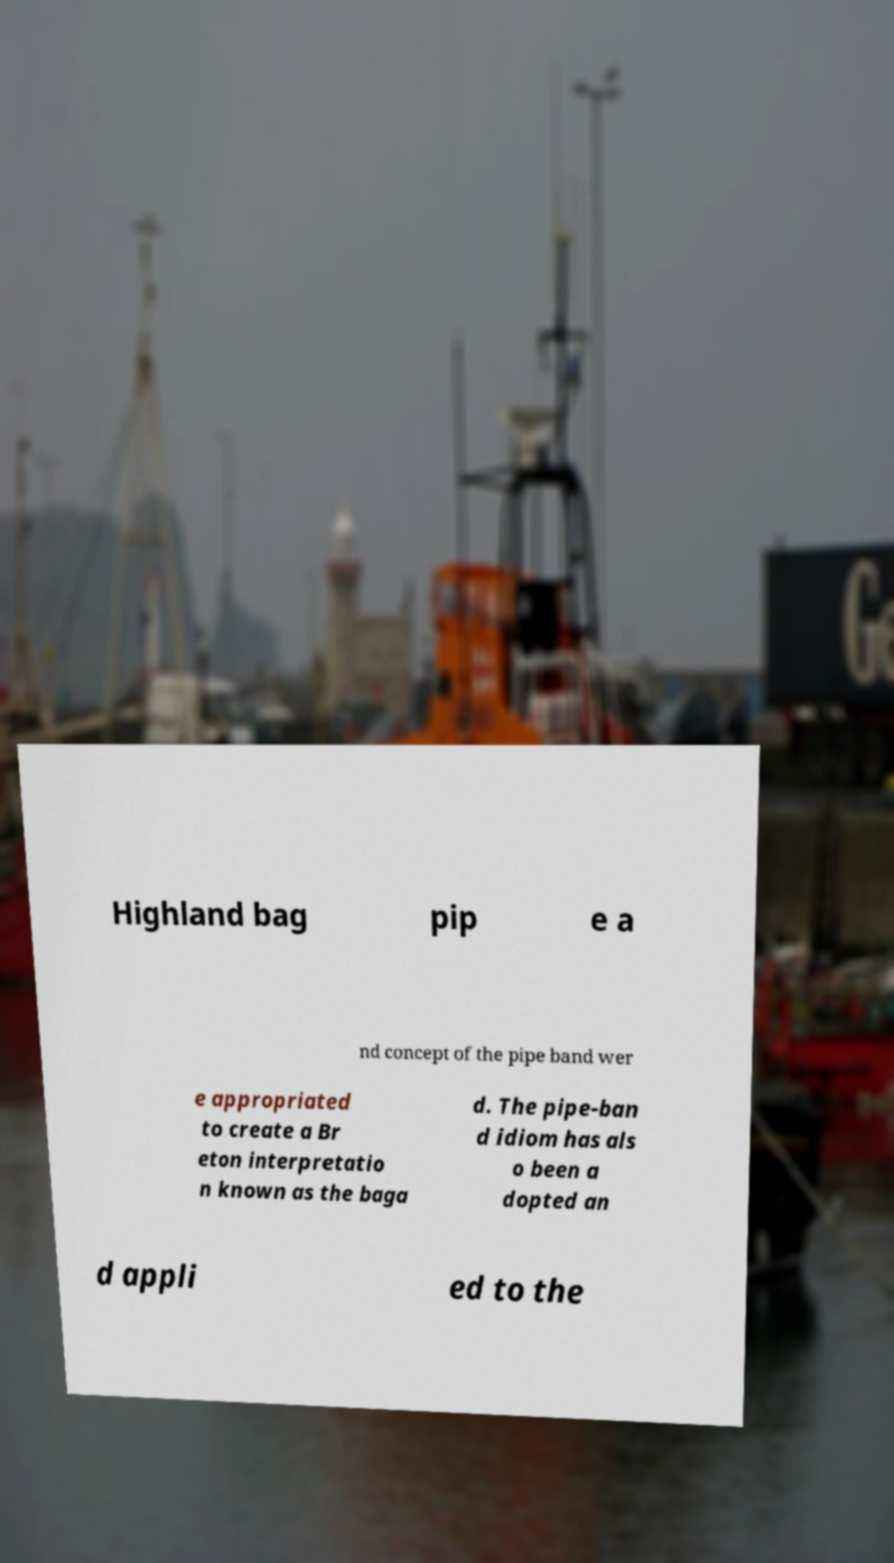Could you assist in decoding the text presented in this image and type it out clearly? Highland bag pip e a nd concept of the pipe band wer e appropriated to create a Br eton interpretatio n known as the baga d. The pipe-ban d idiom has als o been a dopted an d appli ed to the 